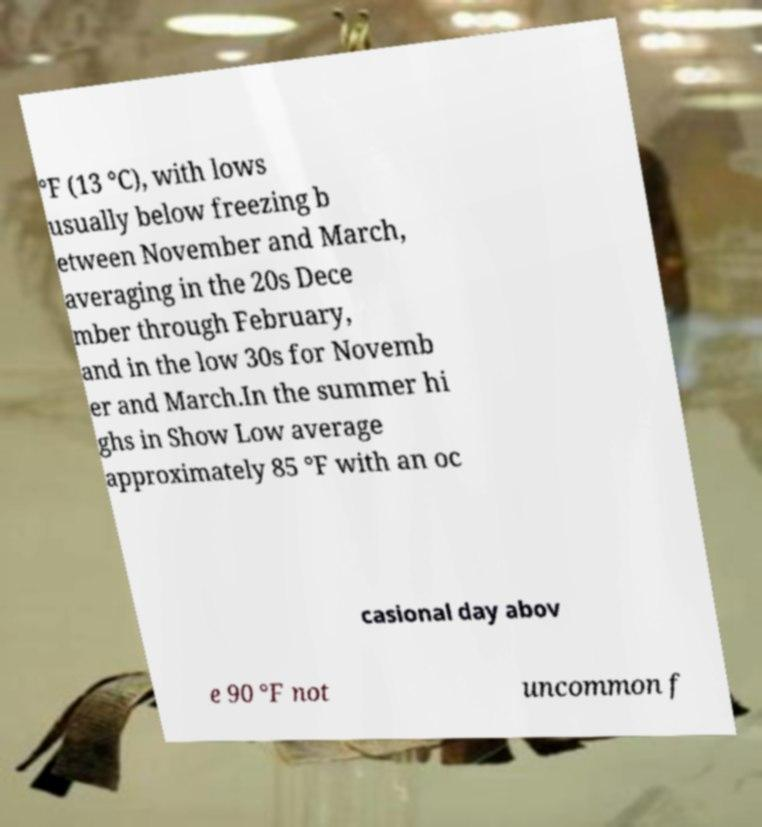What messages or text are displayed in this image? I need them in a readable, typed format. °F (13 °C), with lows usually below freezing b etween November and March, averaging in the 20s Dece mber through February, and in the low 30s for Novemb er and March.In the summer hi ghs in Show Low average approximately 85 °F with an oc casional day abov e 90 °F not uncommon f 